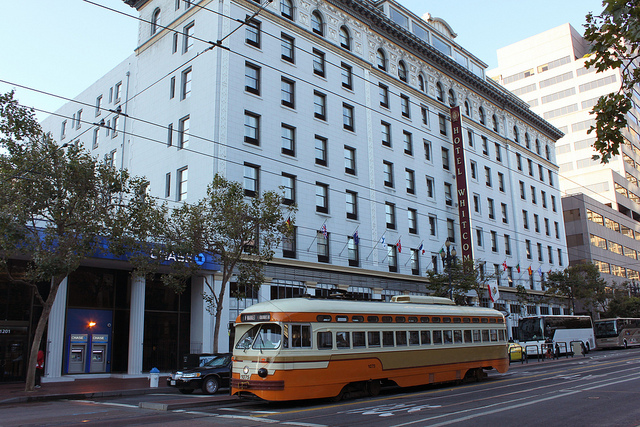Identify and read out the text in this image. HOTEL ITCOM 